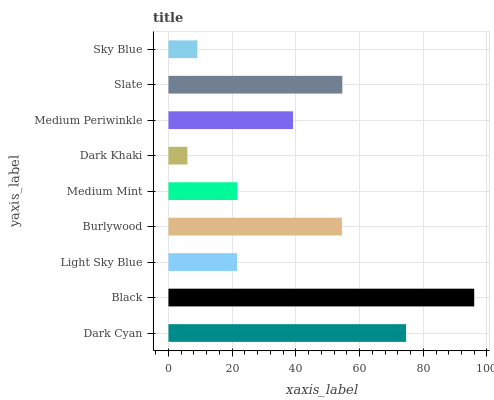Is Dark Khaki the minimum?
Answer yes or no. Yes. Is Black the maximum?
Answer yes or no. Yes. Is Light Sky Blue the minimum?
Answer yes or no. No. Is Light Sky Blue the maximum?
Answer yes or no. No. Is Black greater than Light Sky Blue?
Answer yes or no. Yes. Is Light Sky Blue less than Black?
Answer yes or no. Yes. Is Light Sky Blue greater than Black?
Answer yes or no. No. Is Black less than Light Sky Blue?
Answer yes or no. No. Is Medium Periwinkle the high median?
Answer yes or no. Yes. Is Medium Periwinkle the low median?
Answer yes or no. Yes. Is Burlywood the high median?
Answer yes or no. No. Is Black the low median?
Answer yes or no. No. 